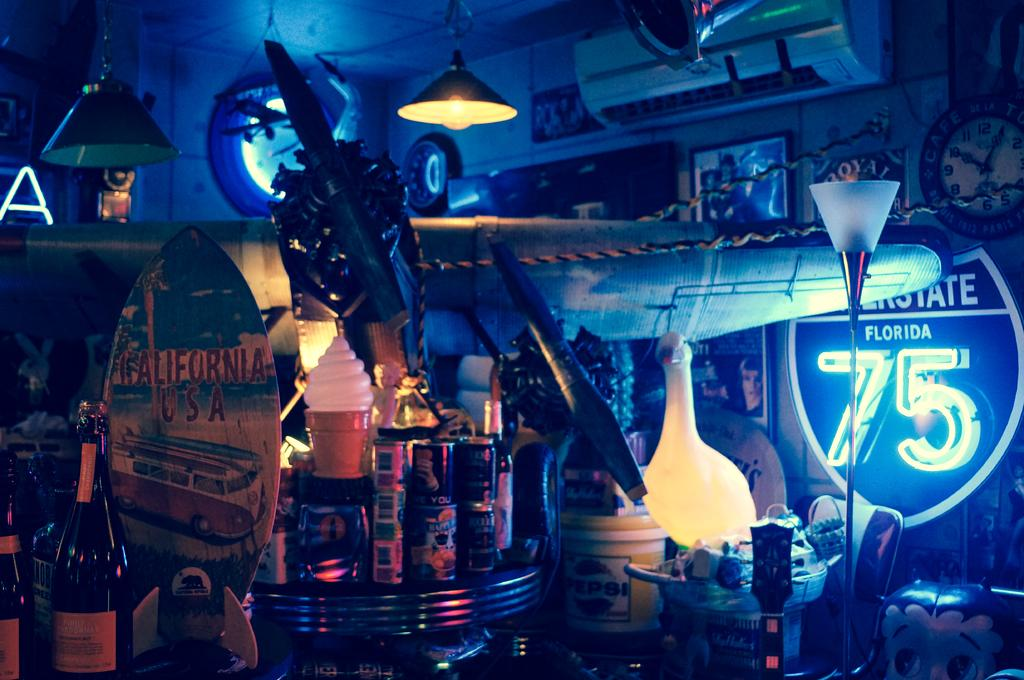<image>
Present a compact description of the photo's key features. Room frilled with a bunch of junk including a glowing sign that says 75 on it. 